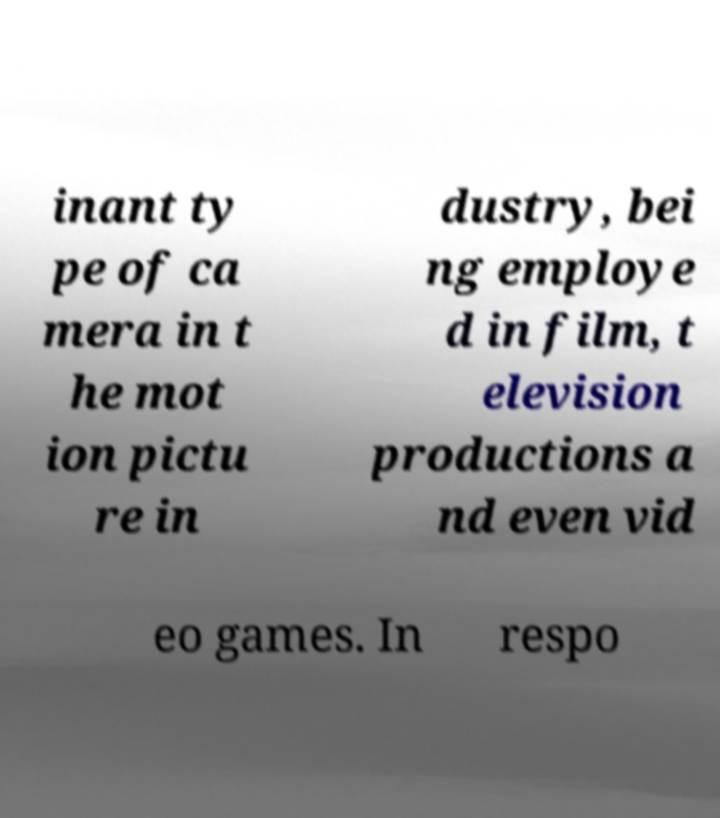Please identify and transcribe the text found in this image. inant ty pe of ca mera in t he mot ion pictu re in dustry, bei ng employe d in film, t elevision productions a nd even vid eo games. In respo 